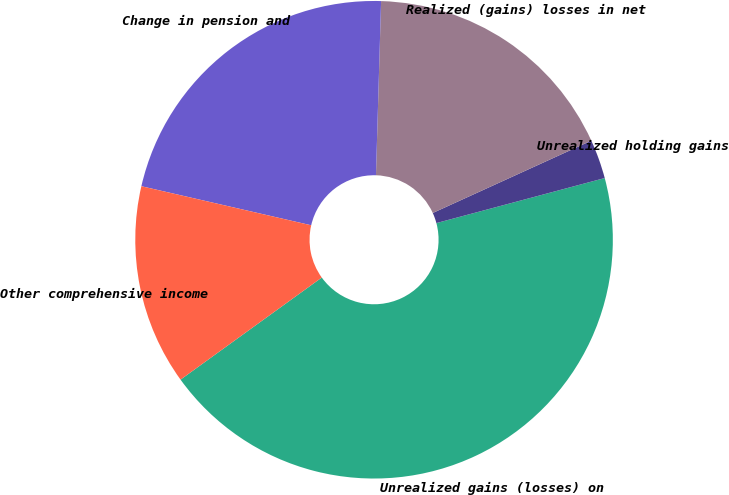Convert chart. <chart><loc_0><loc_0><loc_500><loc_500><pie_chart><fcel>Unrealized gains (losses) on<fcel>Unrealized holding gains<fcel>Realized (gains) losses in net<fcel>Change in pension and<fcel>Other comprehensive income<nl><fcel>44.2%<fcel>2.65%<fcel>17.72%<fcel>21.87%<fcel>13.56%<nl></chart> 